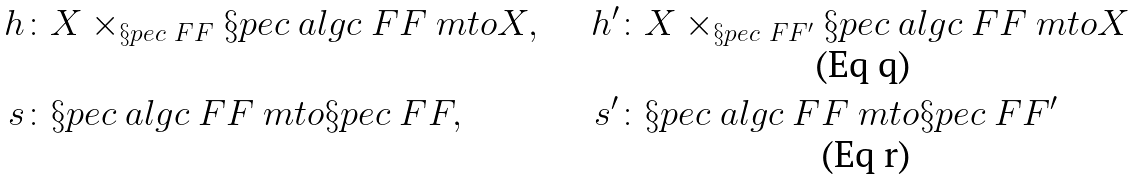Convert formula to latex. <formula><loc_0><loc_0><loc_500><loc_500>h \colon & X \times _ { \S p e c \ F F } \S p e c \ a l g c { \ F F } \ m t o X , & \quad h ^ { \prime } \colon & X \times _ { \S p e c \ F F ^ { \prime } } \S p e c \ a l g c { \ F F } \ m t o X \\ s \colon & \S p e c \ a l g c { \ F F } \ m t o \S p e c \ F F , & \quad s ^ { \prime } \colon & \S p e c \ a l g c { \ F F } \ m t o \S p e c \ F F ^ { \prime }</formula> 